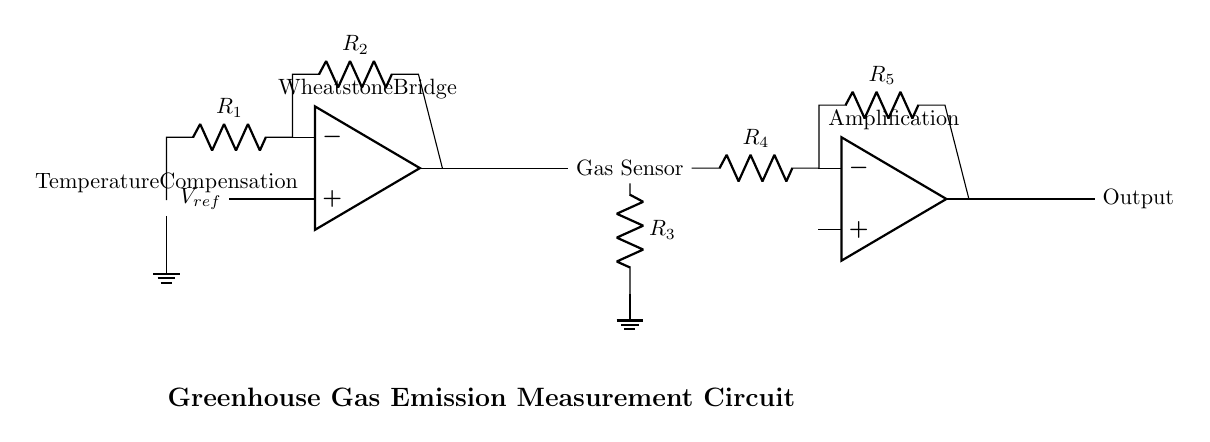What type of temperature sensor is used? The circuit uses a thermistor, which is indicated in the diagram. It is marked as the temperature sensor, providing information that changes with temperature variation.
Answer: thermistor What is the function of the first operational amplifier? The first operational amplifier acts as a Wheatstone bridge, balancing the resistance and making the temperature measurement more stable and accurate. This can be deduced from the label associated with it in the diagram.
Answer: Wheatstone bridge How many resistors are present in the circuit? There are five resistors labeled R1, R2, R3, R4, and R5 in the circuit diagram, which are connected in various configurations for temperature and gas detection.
Answer: five What is the output of the second operational amplifier? The output of the second operational amplifier is labeled as 'Output' in the circuit, directly connected to the preceding components and showing where the final measurement signal is derived.
Answer: Output What role does resistance R3 play in the circuit? Resistance R3 is part of the gas sensor configuration, and it helps to measure the resistance change due to the concentration of greenhouse gases, critical for monitoring emissions. Its position relative to the gas sensor indicates its function in the measurement process.
Answer: Gas Sensor How does temperature compensation occur in this circuit? Temperature compensation is achieved through the thermistor, which adjusts the measurement based on varying temperatures by influencing the first operational amplifier’s inputs, ensuring consistent readings regardless of ambient temperature fluctuations.
Answer: Thermistor 